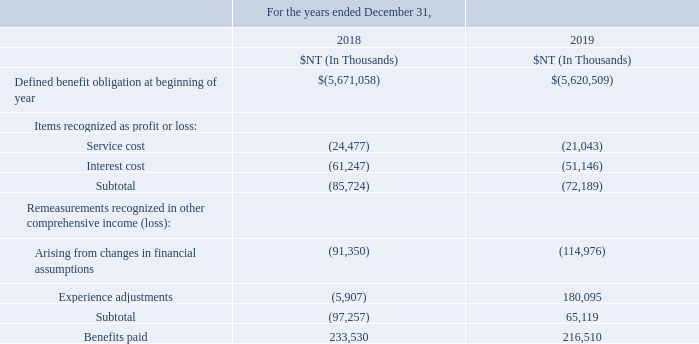The employee pension plan mandated by the Labor Standards Act of the R.O.C. is a defined benefit plan. The pension benefits are disbursed based on the units of service years and average monthly salary prior to retirement according to the Labor Standards Act. Two units per year are awarded for the first 15 years of services while one unit per year is awarded after the completion of the 15th year and the total units will not exceed 45 units.
The Company contributes an amount equivalent to 2% of the employees’ total salaries and wages on a monthly basis to the pension fund deposited with the Bank of Taiwan under the name of a pension fund supervisory committee. The pension fund is managed by the government’s designated authorities and therefore is not included in the Company’s consolidated financial statements. For the years ended December 31, 2017, 2018 and 2019, total pension expenses of NT$80 million, NT$69 million and NT$59 million, respectively, were recognized by the Company.
Movements in present value of defined benefit obligation during the year:
The employee pension plan is mandated under which Act? The labor standards act of the r.o.c. What is the criteria for distributing pension benefits? The pension benefits are disbursed based on the units of service years and average monthly salary prior to retirement according to the labor standards act. What percentage of amount is contributed to the company in the pension fund of an employee? 2%. What is the average Service cost?
Answer scale should be: thousand. (24,477+21,043) / 2
Answer: 22760. What is the average interest cost?
Answer scale should be: thousand. (61,247+51,146) / 2
Answer: 56196.5. What is the increase/ (decrease) in Benefits paid from 2018 to 2019?
Answer scale should be: thousand. 216,510-233,530
Answer: -17020. 